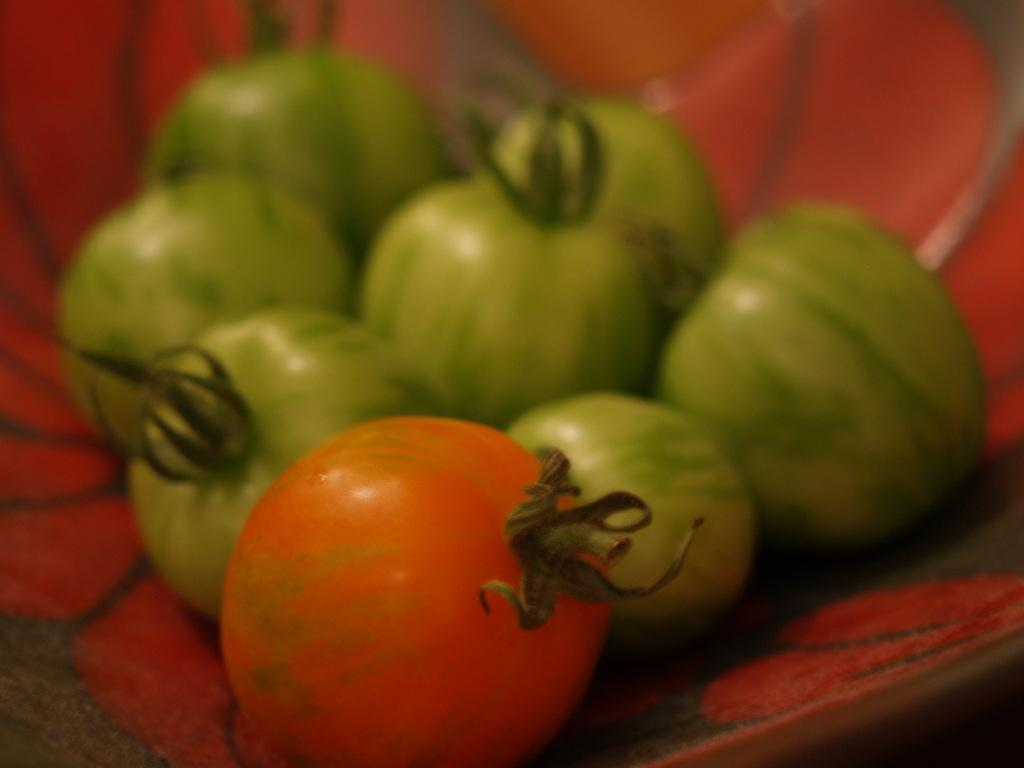What type of food items are present in the image? There are vegetables in the image. How are the vegetables arranged or contained in the image? The vegetables are in a basket. What type of knife is being used by the judge in the image? There is no knife or judge present in the image; it only features vegetables in a basket. 